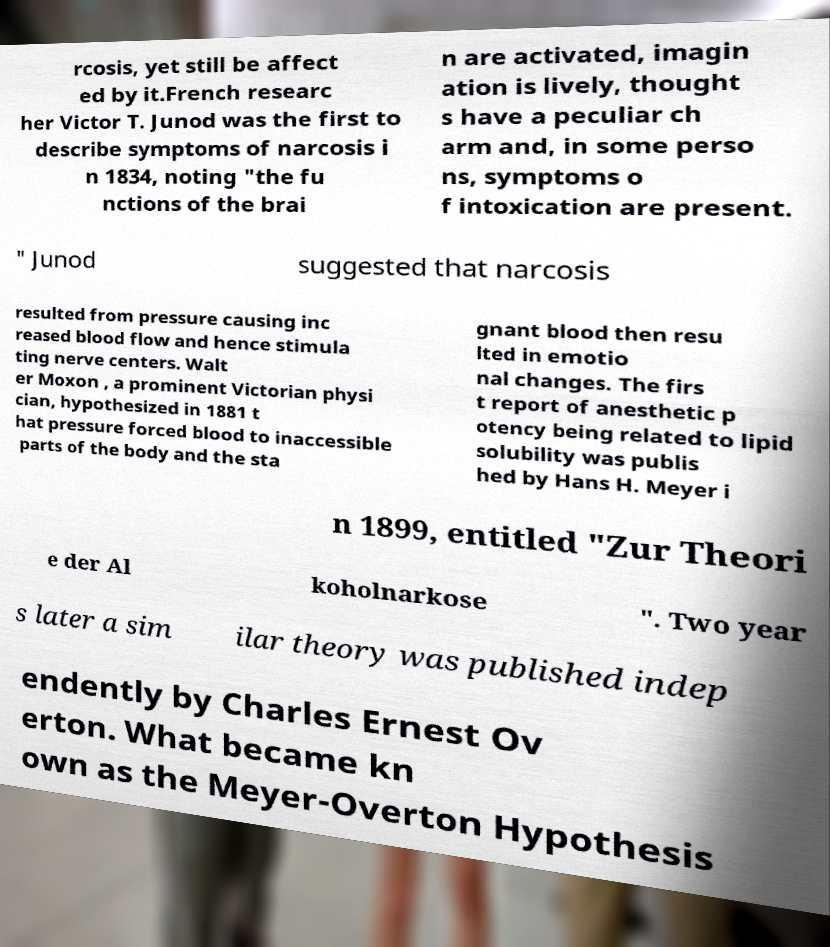I need the written content from this picture converted into text. Can you do that? rcosis, yet still be affect ed by it.French researc her Victor T. Junod was the first to describe symptoms of narcosis i n 1834, noting "the fu nctions of the brai n are activated, imagin ation is lively, thought s have a peculiar ch arm and, in some perso ns, symptoms o f intoxication are present. " Junod suggested that narcosis resulted from pressure causing inc reased blood flow and hence stimula ting nerve centers. Walt er Moxon , a prominent Victorian physi cian, hypothesized in 1881 t hat pressure forced blood to inaccessible parts of the body and the sta gnant blood then resu lted in emotio nal changes. The firs t report of anesthetic p otency being related to lipid solubility was publis hed by Hans H. Meyer i n 1899, entitled "Zur Theori e der Al koholnarkose ". Two year s later a sim ilar theory was published indep endently by Charles Ernest Ov erton. What became kn own as the Meyer-Overton Hypothesis 